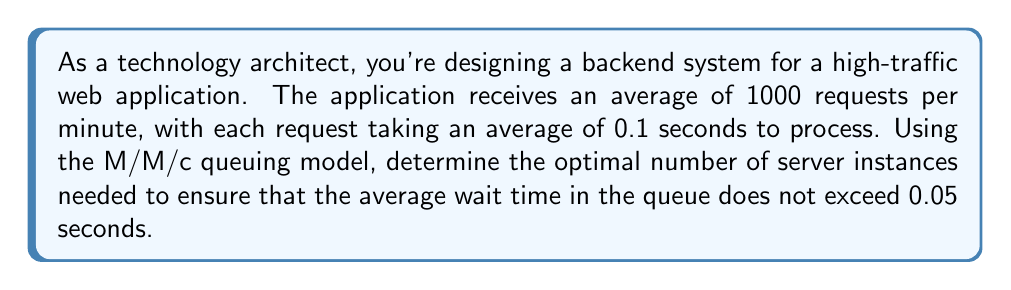Solve this math problem. Let's approach this step-by-step using queuing theory:

1) First, let's identify our parameters:
   $\lambda$ = arrival rate = 1000 requests/minute = 16.67 requests/second
   $\mu$ = service rate = 1/0.1 = 10 requests/second per server
   $W_q$ = average wait time in queue ≤ 0.05 seconds

2) We need to find $c$, the number of servers, such that $W_q \leq 0.05$.

3) In an M/M/c queue, the average wait time in queue is given by:

   $$W_q = \frac{P_0 (\lambda/\mu)^c}{c!(c\mu-\lambda)^2} \cdot \frac{\lambda\mu}{c\mu-\lambda}$$

   Where $P_0$ is the probability of an empty system:

   $$P_0 = \left[\sum_{n=0}^{c-1}\frac{(\lambda/\mu)^n}{n!} + \frac{(\lambda/\mu)^c}{c!(1-\rho)}\right]^{-1}$$

   And $\rho = \frac{\lambda}{c\mu}$ is the system utilization.

4) This equation is complex to solve analytically, so we'll use an iterative approach.

5) Start with the minimum number of servers needed for stability:
   $c_{min} = \lceil \lambda/\mu \rceil = \lceil 16.67/10 \rceil = 2$

6) Calculate $W_q$ for increasing values of $c$ until $W_q \leq 0.05$:

   For $c = 2$: $W_q \approx 0.833$ seconds (too high)
   For $c = 3$: $W_q \approx 0.076$ seconds (too high)
   For $c = 4$: $W_q \approx 0.017$ seconds (meets requirement)

7) Therefore, the optimal number of server instances is 4.
Answer: 4 server instances 